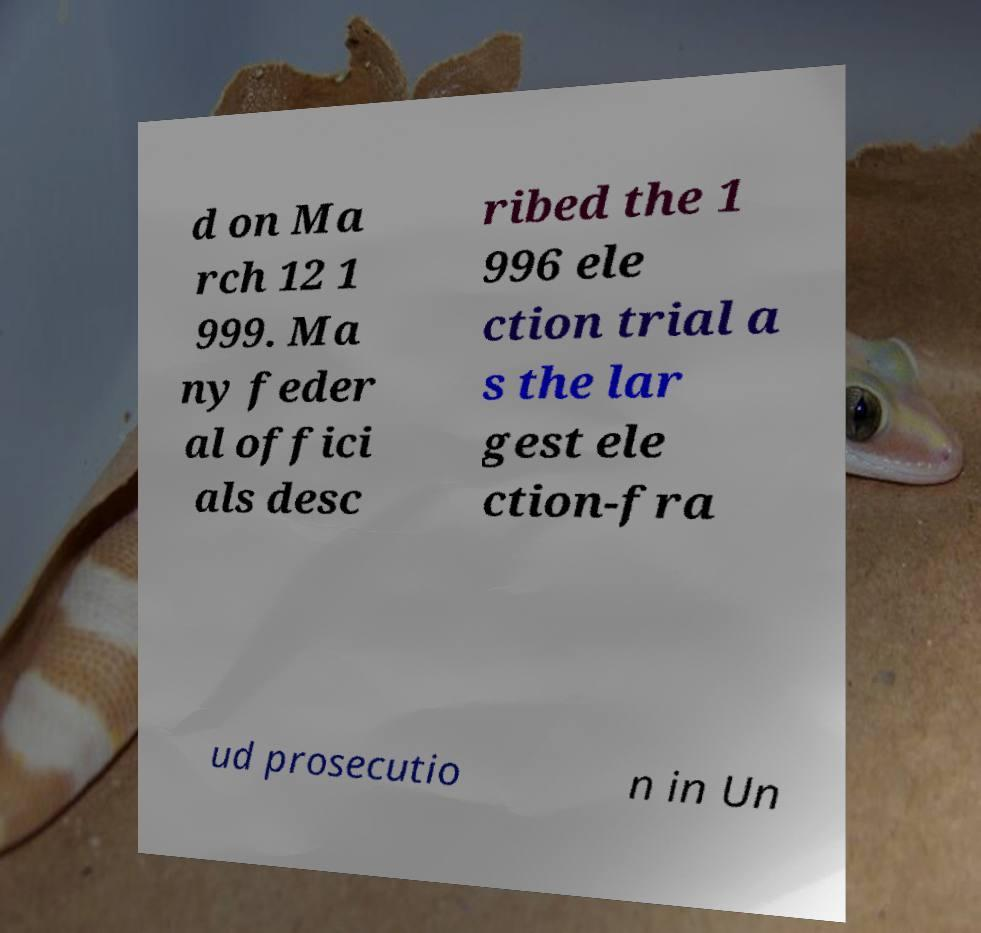Could you extract and type out the text from this image? d on Ma rch 12 1 999. Ma ny feder al offici als desc ribed the 1 996 ele ction trial a s the lar gest ele ction-fra ud prosecutio n in Un 